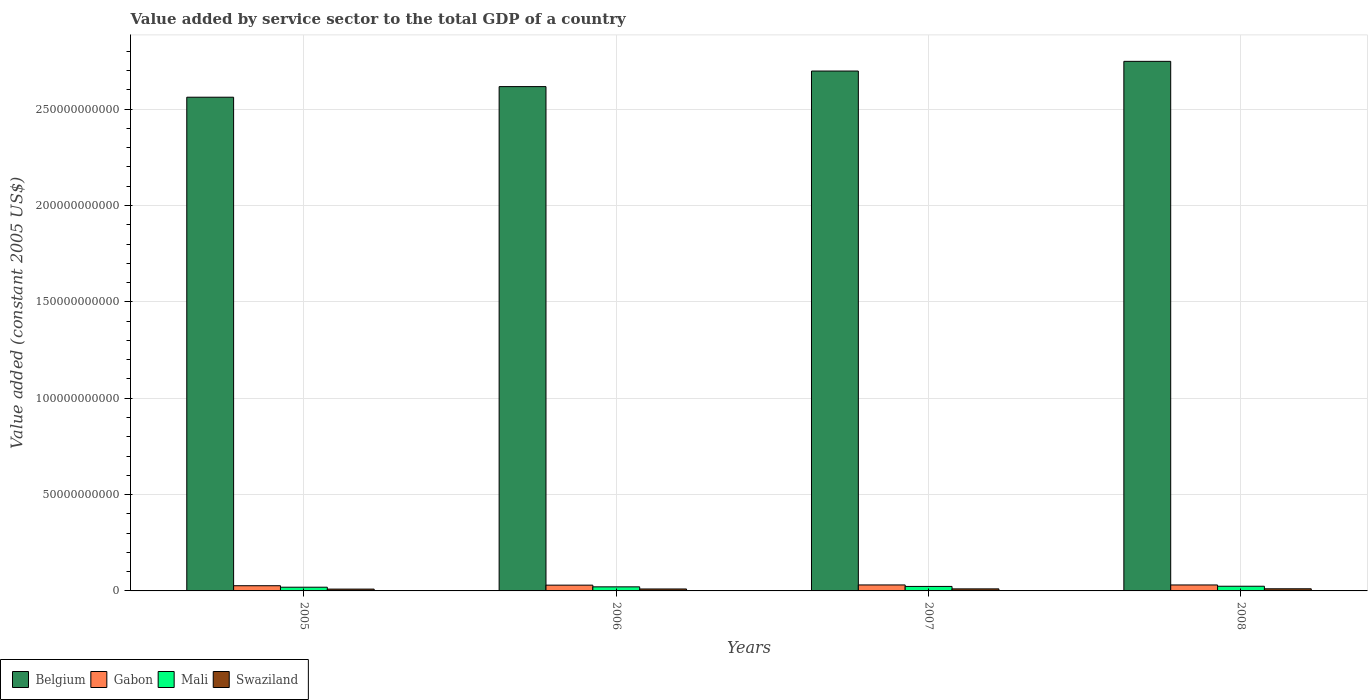How many groups of bars are there?
Offer a terse response. 4. Are the number of bars per tick equal to the number of legend labels?
Offer a terse response. Yes. What is the label of the 1st group of bars from the left?
Your answer should be very brief. 2005. In how many cases, is the number of bars for a given year not equal to the number of legend labels?
Make the answer very short. 0. What is the value added by service sector in Mali in 2005?
Give a very brief answer. 1.93e+09. Across all years, what is the maximum value added by service sector in Mali?
Provide a short and direct response. 2.43e+09. Across all years, what is the minimum value added by service sector in Mali?
Your answer should be very brief. 1.93e+09. In which year was the value added by service sector in Mali maximum?
Keep it short and to the point. 2008. What is the total value added by service sector in Belgium in the graph?
Ensure brevity in your answer.  1.06e+12. What is the difference between the value added by service sector in Gabon in 2006 and that in 2007?
Provide a short and direct response. -1.08e+08. What is the difference between the value added by service sector in Belgium in 2007 and the value added by service sector in Gabon in 2005?
Ensure brevity in your answer.  2.67e+11. What is the average value added by service sector in Gabon per year?
Provide a short and direct response. 2.97e+09. In the year 2008, what is the difference between the value added by service sector in Gabon and value added by service sector in Mali?
Keep it short and to the point. 6.67e+08. In how many years, is the value added by service sector in Belgium greater than 20000000000 US$?
Keep it short and to the point. 4. What is the ratio of the value added by service sector in Mali in 2005 to that in 2006?
Provide a succinct answer. 0.91. Is the value added by service sector in Gabon in 2006 less than that in 2007?
Your response must be concise. Yes. Is the difference between the value added by service sector in Gabon in 2006 and 2008 greater than the difference between the value added by service sector in Mali in 2006 and 2008?
Offer a terse response. Yes. What is the difference between the highest and the second highest value added by service sector in Gabon?
Offer a very short reply. 8.14e+06. What is the difference between the highest and the lowest value added by service sector in Gabon?
Offer a terse response. 4.02e+08. In how many years, is the value added by service sector in Swaziland greater than the average value added by service sector in Swaziland taken over all years?
Give a very brief answer. 2. Is the sum of the value added by service sector in Swaziland in 2005 and 2006 greater than the maximum value added by service sector in Belgium across all years?
Your answer should be very brief. No. Is it the case that in every year, the sum of the value added by service sector in Mali and value added by service sector in Belgium is greater than the sum of value added by service sector in Swaziland and value added by service sector in Gabon?
Make the answer very short. Yes. What does the 4th bar from the left in 2007 represents?
Offer a terse response. Swaziland. What does the 2nd bar from the right in 2005 represents?
Provide a succinct answer. Mali. Is it the case that in every year, the sum of the value added by service sector in Belgium and value added by service sector in Swaziland is greater than the value added by service sector in Mali?
Provide a succinct answer. Yes. Are all the bars in the graph horizontal?
Keep it short and to the point. No. Does the graph contain any zero values?
Give a very brief answer. No. Does the graph contain grids?
Offer a very short reply. Yes. How many legend labels are there?
Your response must be concise. 4. What is the title of the graph?
Make the answer very short. Value added by service sector to the total GDP of a country. What is the label or title of the X-axis?
Your answer should be compact. Years. What is the label or title of the Y-axis?
Offer a terse response. Value added (constant 2005 US$). What is the Value added (constant 2005 US$) of Belgium in 2005?
Provide a succinct answer. 2.56e+11. What is the Value added (constant 2005 US$) of Gabon in 2005?
Your answer should be compact. 2.70e+09. What is the Value added (constant 2005 US$) in Mali in 2005?
Make the answer very short. 1.93e+09. What is the Value added (constant 2005 US$) of Swaziland in 2005?
Make the answer very short. 9.48e+08. What is the Value added (constant 2005 US$) of Belgium in 2006?
Make the answer very short. 2.62e+11. What is the Value added (constant 2005 US$) of Gabon in 2006?
Provide a short and direct response. 2.99e+09. What is the Value added (constant 2005 US$) of Mali in 2006?
Keep it short and to the point. 2.11e+09. What is the Value added (constant 2005 US$) of Swaziland in 2006?
Your response must be concise. 1.01e+09. What is the Value added (constant 2005 US$) of Belgium in 2007?
Give a very brief answer. 2.70e+11. What is the Value added (constant 2005 US$) of Gabon in 2007?
Make the answer very short. 3.10e+09. What is the Value added (constant 2005 US$) of Mali in 2007?
Ensure brevity in your answer.  2.33e+09. What is the Value added (constant 2005 US$) in Swaziland in 2007?
Your answer should be compact. 1.06e+09. What is the Value added (constant 2005 US$) of Belgium in 2008?
Offer a terse response. 2.75e+11. What is the Value added (constant 2005 US$) in Gabon in 2008?
Provide a short and direct response. 3.09e+09. What is the Value added (constant 2005 US$) of Mali in 2008?
Your response must be concise. 2.43e+09. What is the Value added (constant 2005 US$) in Swaziland in 2008?
Make the answer very short. 1.10e+09. Across all years, what is the maximum Value added (constant 2005 US$) in Belgium?
Provide a succinct answer. 2.75e+11. Across all years, what is the maximum Value added (constant 2005 US$) of Gabon?
Offer a very short reply. 3.10e+09. Across all years, what is the maximum Value added (constant 2005 US$) of Mali?
Offer a very short reply. 2.43e+09. Across all years, what is the maximum Value added (constant 2005 US$) of Swaziland?
Give a very brief answer. 1.10e+09. Across all years, what is the minimum Value added (constant 2005 US$) in Belgium?
Provide a short and direct response. 2.56e+11. Across all years, what is the minimum Value added (constant 2005 US$) of Gabon?
Provide a short and direct response. 2.70e+09. Across all years, what is the minimum Value added (constant 2005 US$) in Mali?
Your answer should be very brief. 1.93e+09. Across all years, what is the minimum Value added (constant 2005 US$) in Swaziland?
Give a very brief answer. 9.48e+08. What is the total Value added (constant 2005 US$) of Belgium in the graph?
Ensure brevity in your answer.  1.06e+12. What is the total Value added (constant 2005 US$) in Gabon in the graph?
Provide a short and direct response. 1.19e+1. What is the total Value added (constant 2005 US$) in Mali in the graph?
Your answer should be compact. 8.79e+09. What is the total Value added (constant 2005 US$) in Swaziland in the graph?
Make the answer very short. 4.12e+09. What is the difference between the Value added (constant 2005 US$) in Belgium in 2005 and that in 2006?
Your answer should be very brief. -5.51e+09. What is the difference between the Value added (constant 2005 US$) in Gabon in 2005 and that in 2006?
Provide a succinct answer. -2.94e+08. What is the difference between the Value added (constant 2005 US$) of Mali in 2005 and that in 2006?
Offer a terse response. -1.81e+08. What is the difference between the Value added (constant 2005 US$) in Swaziland in 2005 and that in 2006?
Provide a short and direct response. -5.94e+07. What is the difference between the Value added (constant 2005 US$) of Belgium in 2005 and that in 2007?
Your answer should be compact. -1.36e+1. What is the difference between the Value added (constant 2005 US$) in Gabon in 2005 and that in 2007?
Your response must be concise. -4.02e+08. What is the difference between the Value added (constant 2005 US$) of Mali in 2005 and that in 2007?
Offer a very short reply. -4.00e+08. What is the difference between the Value added (constant 2005 US$) in Swaziland in 2005 and that in 2007?
Ensure brevity in your answer.  -1.12e+08. What is the difference between the Value added (constant 2005 US$) of Belgium in 2005 and that in 2008?
Offer a very short reply. -1.86e+1. What is the difference between the Value added (constant 2005 US$) of Gabon in 2005 and that in 2008?
Your response must be concise. -3.94e+08. What is the difference between the Value added (constant 2005 US$) in Mali in 2005 and that in 2008?
Offer a terse response. -4.99e+08. What is the difference between the Value added (constant 2005 US$) in Swaziland in 2005 and that in 2008?
Provide a succinct answer. -1.55e+08. What is the difference between the Value added (constant 2005 US$) of Belgium in 2006 and that in 2007?
Your response must be concise. -8.08e+09. What is the difference between the Value added (constant 2005 US$) in Gabon in 2006 and that in 2007?
Provide a short and direct response. -1.08e+08. What is the difference between the Value added (constant 2005 US$) in Mali in 2006 and that in 2007?
Make the answer very short. -2.19e+08. What is the difference between the Value added (constant 2005 US$) in Swaziland in 2006 and that in 2007?
Your answer should be very brief. -5.28e+07. What is the difference between the Value added (constant 2005 US$) in Belgium in 2006 and that in 2008?
Your answer should be very brief. -1.31e+1. What is the difference between the Value added (constant 2005 US$) of Gabon in 2006 and that in 2008?
Offer a terse response. -9.95e+07. What is the difference between the Value added (constant 2005 US$) of Mali in 2006 and that in 2008?
Your response must be concise. -3.18e+08. What is the difference between the Value added (constant 2005 US$) of Swaziland in 2006 and that in 2008?
Provide a succinct answer. -9.55e+07. What is the difference between the Value added (constant 2005 US$) of Belgium in 2007 and that in 2008?
Your answer should be compact. -5.02e+09. What is the difference between the Value added (constant 2005 US$) in Gabon in 2007 and that in 2008?
Offer a very short reply. 8.14e+06. What is the difference between the Value added (constant 2005 US$) in Mali in 2007 and that in 2008?
Your answer should be compact. -9.94e+07. What is the difference between the Value added (constant 2005 US$) in Swaziland in 2007 and that in 2008?
Ensure brevity in your answer.  -4.27e+07. What is the difference between the Value added (constant 2005 US$) of Belgium in 2005 and the Value added (constant 2005 US$) of Gabon in 2006?
Keep it short and to the point. 2.53e+11. What is the difference between the Value added (constant 2005 US$) of Belgium in 2005 and the Value added (constant 2005 US$) of Mali in 2006?
Your answer should be compact. 2.54e+11. What is the difference between the Value added (constant 2005 US$) in Belgium in 2005 and the Value added (constant 2005 US$) in Swaziland in 2006?
Offer a very short reply. 2.55e+11. What is the difference between the Value added (constant 2005 US$) in Gabon in 2005 and the Value added (constant 2005 US$) in Mali in 2006?
Give a very brief answer. 5.91e+08. What is the difference between the Value added (constant 2005 US$) in Gabon in 2005 and the Value added (constant 2005 US$) in Swaziland in 2006?
Your answer should be very brief. 1.69e+09. What is the difference between the Value added (constant 2005 US$) of Mali in 2005 and the Value added (constant 2005 US$) of Swaziland in 2006?
Give a very brief answer. 9.20e+08. What is the difference between the Value added (constant 2005 US$) in Belgium in 2005 and the Value added (constant 2005 US$) in Gabon in 2007?
Ensure brevity in your answer.  2.53e+11. What is the difference between the Value added (constant 2005 US$) of Belgium in 2005 and the Value added (constant 2005 US$) of Mali in 2007?
Provide a short and direct response. 2.54e+11. What is the difference between the Value added (constant 2005 US$) of Belgium in 2005 and the Value added (constant 2005 US$) of Swaziland in 2007?
Ensure brevity in your answer.  2.55e+11. What is the difference between the Value added (constant 2005 US$) of Gabon in 2005 and the Value added (constant 2005 US$) of Mali in 2007?
Your answer should be very brief. 3.72e+08. What is the difference between the Value added (constant 2005 US$) of Gabon in 2005 and the Value added (constant 2005 US$) of Swaziland in 2007?
Give a very brief answer. 1.64e+09. What is the difference between the Value added (constant 2005 US$) of Mali in 2005 and the Value added (constant 2005 US$) of Swaziland in 2007?
Offer a terse response. 8.67e+08. What is the difference between the Value added (constant 2005 US$) of Belgium in 2005 and the Value added (constant 2005 US$) of Gabon in 2008?
Your response must be concise. 2.53e+11. What is the difference between the Value added (constant 2005 US$) in Belgium in 2005 and the Value added (constant 2005 US$) in Mali in 2008?
Your response must be concise. 2.54e+11. What is the difference between the Value added (constant 2005 US$) in Belgium in 2005 and the Value added (constant 2005 US$) in Swaziland in 2008?
Your response must be concise. 2.55e+11. What is the difference between the Value added (constant 2005 US$) of Gabon in 2005 and the Value added (constant 2005 US$) of Mali in 2008?
Provide a short and direct response. 2.73e+08. What is the difference between the Value added (constant 2005 US$) of Gabon in 2005 and the Value added (constant 2005 US$) of Swaziland in 2008?
Your answer should be compact. 1.60e+09. What is the difference between the Value added (constant 2005 US$) of Mali in 2005 and the Value added (constant 2005 US$) of Swaziland in 2008?
Provide a short and direct response. 8.24e+08. What is the difference between the Value added (constant 2005 US$) of Belgium in 2006 and the Value added (constant 2005 US$) of Gabon in 2007?
Make the answer very short. 2.59e+11. What is the difference between the Value added (constant 2005 US$) in Belgium in 2006 and the Value added (constant 2005 US$) in Mali in 2007?
Provide a short and direct response. 2.59e+11. What is the difference between the Value added (constant 2005 US$) of Belgium in 2006 and the Value added (constant 2005 US$) of Swaziland in 2007?
Ensure brevity in your answer.  2.61e+11. What is the difference between the Value added (constant 2005 US$) in Gabon in 2006 and the Value added (constant 2005 US$) in Mali in 2007?
Make the answer very short. 6.67e+08. What is the difference between the Value added (constant 2005 US$) in Gabon in 2006 and the Value added (constant 2005 US$) in Swaziland in 2007?
Keep it short and to the point. 1.93e+09. What is the difference between the Value added (constant 2005 US$) in Mali in 2006 and the Value added (constant 2005 US$) in Swaziland in 2007?
Your answer should be compact. 1.05e+09. What is the difference between the Value added (constant 2005 US$) in Belgium in 2006 and the Value added (constant 2005 US$) in Gabon in 2008?
Your answer should be compact. 2.59e+11. What is the difference between the Value added (constant 2005 US$) of Belgium in 2006 and the Value added (constant 2005 US$) of Mali in 2008?
Your response must be concise. 2.59e+11. What is the difference between the Value added (constant 2005 US$) of Belgium in 2006 and the Value added (constant 2005 US$) of Swaziland in 2008?
Your response must be concise. 2.61e+11. What is the difference between the Value added (constant 2005 US$) of Gabon in 2006 and the Value added (constant 2005 US$) of Mali in 2008?
Ensure brevity in your answer.  5.67e+08. What is the difference between the Value added (constant 2005 US$) in Gabon in 2006 and the Value added (constant 2005 US$) in Swaziland in 2008?
Provide a succinct answer. 1.89e+09. What is the difference between the Value added (constant 2005 US$) in Mali in 2006 and the Value added (constant 2005 US$) in Swaziland in 2008?
Your answer should be very brief. 1.01e+09. What is the difference between the Value added (constant 2005 US$) in Belgium in 2007 and the Value added (constant 2005 US$) in Gabon in 2008?
Give a very brief answer. 2.67e+11. What is the difference between the Value added (constant 2005 US$) of Belgium in 2007 and the Value added (constant 2005 US$) of Mali in 2008?
Your answer should be very brief. 2.67e+11. What is the difference between the Value added (constant 2005 US$) in Belgium in 2007 and the Value added (constant 2005 US$) in Swaziland in 2008?
Make the answer very short. 2.69e+11. What is the difference between the Value added (constant 2005 US$) in Gabon in 2007 and the Value added (constant 2005 US$) in Mali in 2008?
Ensure brevity in your answer.  6.75e+08. What is the difference between the Value added (constant 2005 US$) of Gabon in 2007 and the Value added (constant 2005 US$) of Swaziland in 2008?
Provide a succinct answer. 2.00e+09. What is the difference between the Value added (constant 2005 US$) of Mali in 2007 and the Value added (constant 2005 US$) of Swaziland in 2008?
Make the answer very short. 1.22e+09. What is the average Value added (constant 2005 US$) of Belgium per year?
Ensure brevity in your answer.  2.66e+11. What is the average Value added (constant 2005 US$) in Gabon per year?
Keep it short and to the point. 2.97e+09. What is the average Value added (constant 2005 US$) in Mali per year?
Provide a short and direct response. 2.20e+09. What is the average Value added (constant 2005 US$) in Swaziland per year?
Make the answer very short. 1.03e+09. In the year 2005, what is the difference between the Value added (constant 2005 US$) in Belgium and Value added (constant 2005 US$) in Gabon?
Provide a succinct answer. 2.53e+11. In the year 2005, what is the difference between the Value added (constant 2005 US$) of Belgium and Value added (constant 2005 US$) of Mali?
Provide a short and direct response. 2.54e+11. In the year 2005, what is the difference between the Value added (constant 2005 US$) of Belgium and Value added (constant 2005 US$) of Swaziland?
Keep it short and to the point. 2.55e+11. In the year 2005, what is the difference between the Value added (constant 2005 US$) in Gabon and Value added (constant 2005 US$) in Mali?
Provide a short and direct response. 7.72e+08. In the year 2005, what is the difference between the Value added (constant 2005 US$) of Gabon and Value added (constant 2005 US$) of Swaziland?
Give a very brief answer. 1.75e+09. In the year 2005, what is the difference between the Value added (constant 2005 US$) of Mali and Value added (constant 2005 US$) of Swaziland?
Your answer should be very brief. 9.79e+08. In the year 2006, what is the difference between the Value added (constant 2005 US$) in Belgium and Value added (constant 2005 US$) in Gabon?
Offer a terse response. 2.59e+11. In the year 2006, what is the difference between the Value added (constant 2005 US$) in Belgium and Value added (constant 2005 US$) in Mali?
Provide a short and direct response. 2.60e+11. In the year 2006, what is the difference between the Value added (constant 2005 US$) in Belgium and Value added (constant 2005 US$) in Swaziland?
Your answer should be very brief. 2.61e+11. In the year 2006, what is the difference between the Value added (constant 2005 US$) of Gabon and Value added (constant 2005 US$) of Mali?
Offer a terse response. 8.86e+08. In the year 2006, what is the difference between the Value added (constant 2005 US$) of Gabon and Value added (constant 2005 US$) of Swaziland?
Give a very brief answer. 1.99e+09. In the year 2006, what is the difference between the Value added (constant 2005 US$) of Mali and Value added (constant 2005 US$) of Swaziland?
Provide a succinct answer. 1.10e+09. In the year 2007, what is the difference between the Value added (constant 2005 US$) of Belgium and Value added (constant 2005 US$) of Gabon?
Your answer should be compact. 2.67e+11. In the year 2007, what is the difference between the Value added (constant 2005 US$) of Belgium and Value added (constant 2005 US$) of Mali?
Give a very brief answer. 2.67e+11. In the year 2007, what is the difference between the Value added (constant 2005 US$) of Belgium and Value added (constant 2005 US$) of Swaziland?
Offer a very short reply. 2.69e+11. In the year 2007, what is the difference between the Value added (constant 2005 US$) in Gabon and Value added (constant 2005 US$) in Mali?
Offer a terse response. 7.74e+08. In the year 2007, what is the difference between the Value added (constant 2005 US$) of Gabon and Value added (constant 2005 US$) of Swaziland?
Offer a terse response. 2.04e+09. In the year 2007, what is the difference between the Value added (constant 2005 US$) in Mali and Value added (constant 2005 US$) in Swaziland?
Offer a very short reply. 1.27e+09. In the year 2008, what is the difference between the Value added (constant 2005 US$) in Belgium and Value added (constant 2005 US$) in Gabon?
Ensure brevity in your answer.  2.72e+11. In the year 2008, what is the difference between the Value added (constant 2005 US$) of Belgium and Value added (constant 2005 US$) of Mali?
Ensure brevity in your answer.  2.72e+11. In the year 2008, what is the difference between the Value added (constant 2005 US$) of Belgium and Value added (constant 2005 US$) of Swaziland?
Your response must be concise. 2.74e+11. In the year 2008, what is the difference between the Value added (constant 2005 US$) in Gabon and Value added (constant 2005 US$) in Mali?
Give a very brief answer. 6.67e+08. In the year 2008, what is the difference between the Value added (constant 2005 US$) in Gabon and Value added (constant 2005 US$) in Swaziland?
Your response must be concise. 1.99e+09. In the year 2008, what is the difference between the Value added (constant 2005 US$) of Mali and Value added (constant 2005 US$) of Swaziland?
Offer a terse response. 1.32e+09. What is the ratio of the Value added (constant 2005 US$) of Belgium in 2005 to that in 2006?
Your answer should be compact. 0.98. What is the ratio of the Value added (constant 2005 US$) of Gabon in 2005 to that in 2006?
Provide a succinct answer. 0.9. What is the ratio of the Value added (constant 2005 US$) in Mali in 2005 to that in 2006?
Provide a succinct answer. 0.91. What is the ratio of the Value added (constant 2005 US$) of Swaziland in 2005 to that in 2006?
Offer a terse response. 0.94. What is the ratio of the Value added (constant 2005 US$) in Belgium in 2005 to that in 2007?
Give a very brief answer. 0.95. What is the ratio of the Value added (constant 2005 US$) in Gabon in 2005 to that in 2007?
Offer a very short reply. 0.87. What is the ratio of the Value added (constant 2005 US$) in Mali in 2005 to that in 2007?
Keep it short and to the point. 0.83. What is the ratio of the Value added (constant 2005 US$) of Swaziland in 2005 to that in 2007?
Keep it short and to the point. 0.89. What is the ratio of the Value added (constant 2005 US$) of Belgium in 2005 to that in 2008?
Provide a short and direct response. 0.93. What is the ratio of the Value added (constant 2005 US$) of Gabon in 2005 to that in 2008?
Your response must be concise. 0.87. What is the ratio of the Value added (constant 2005 US$) of Mali in 2005 to that in 2008?
Keep it short and to the point. 0.79. What is the ratio of the Value added (constant 2005 US$) of Swaziland in 2005 to that in 2008?
Provide a short and direct response. 0.86. What is the ratio of the Value added (constant 2005 US$) in Belgium in 2006 to that in 2007?
Give a very brief answer. 0.97. What is the ratio of the Value added (constant 2005 US$) of Gabon in 2006 to that in 2007?
Give a very brief answer. 0.97. What is the ratio of the Value added (constant 2005 US$) of Mali in 2006 to that in 2007?
Offer a terse response. 0.91. What is the ratio of the Value added (constant 2005 US$) in Swaziland in 2006 to that in 2007?
Make the answer very short. 0.95. What is the ratio of the Value added (constant 2005 US$) of Belgium in 2006 to that in 2008?
Offer a very short reply. 0.95. What is the ratio of the Value added (constant 2005 US$) of Gabon in 2006 to that in 2008?
Provide a succinct answer. 0.97. What is the ratio of the Value added (constant 2005 US$) of Mali in 2006 to that in 2008?
Your answer should be compact. 0.87. What is the ratio of the Value added (constant 2005 US$) of Swaziland in 2006 to that in 2008?
Ensure brevity in your answer.  0.91. What is the ratio of the Value added (constant 2005 US$) of Belgium in 2007 to that in 2008?
Your answer should be very brief. 0.98. What is the ratio of the Value added (constant 2005 US$) of Mali in 2007 to that in 2008?
Keep it short and to the point. 0.96. What is the ratio of the Value added (constant 2005 US$) of Swaziland in 2007 to that in 2008?
Give a very brief answer. 0.96. What is the difference between the highest and the second highest Value added (constant 2005 US$) of Belgium?
Make the answer very short. 5.02e+09. What is the difference between the highest and the second highest Value added (constant 2005 US$) of Gabon?
Your answer should be very brief. 8.14e+06. What is the difference between the highest and the second highest Value added (constant 2005 US$) in Mali?
Your answer should be very brief. 9.94e+07. What is the difference between the highest and the second highest Value added (constant 2005 US$) in Swaziland?
Make the answer very short. 4.27e+07. What is the difference between the highest and the lowest Value added (constant 2005 US$) in Belgium?
Your answer should be very brief. 1.86e+1. What is the difference between the highest and the lowest Value added (constant 2005 US$) of Gabon?
Make the answer very short. 4.02e+08. What is the difference between the highest and the lowest Value added (constant 2005 US$) of Mali?
Offer a terse response. 4.99e+08. What is the difference between the highest and the lowest Value added (constant 2005 US$) of Swaziland?
Your answer should be very brief. 1.55e+08. 